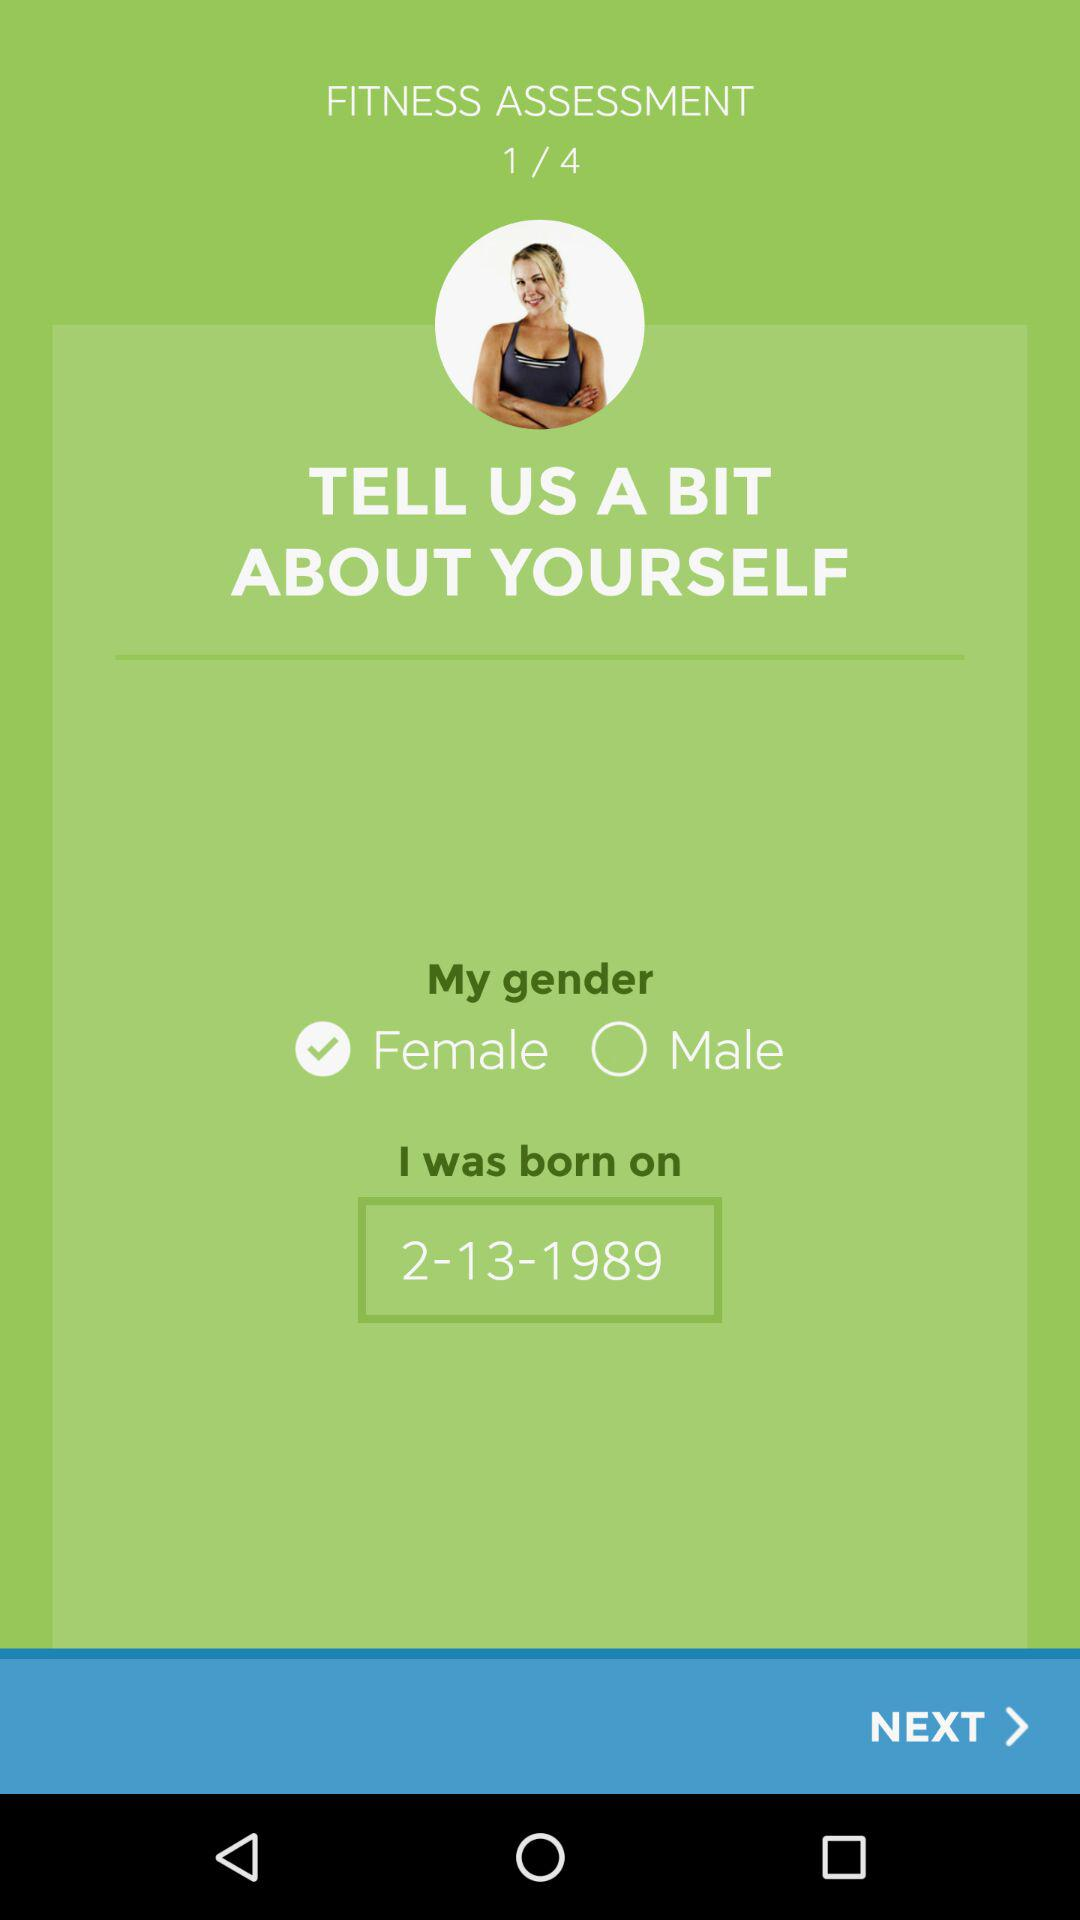At which fitness assessment am I at? You are at fitness assessment 1. 